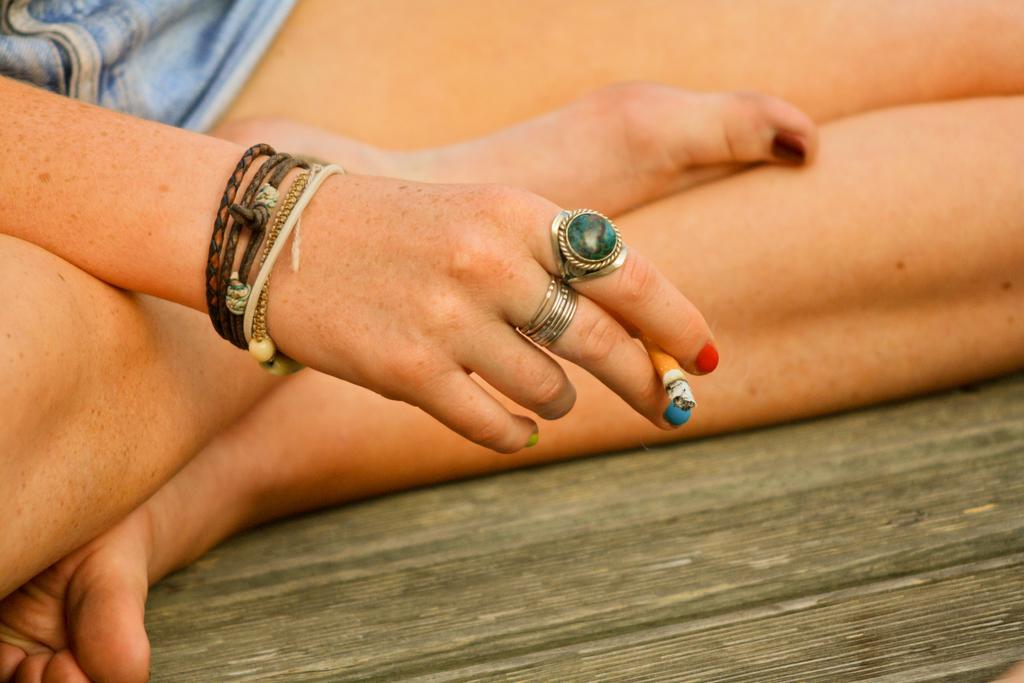Describe this image in one or two sentences. In this image I can see a person hand and the legs. I can see two rings on the fingers. 